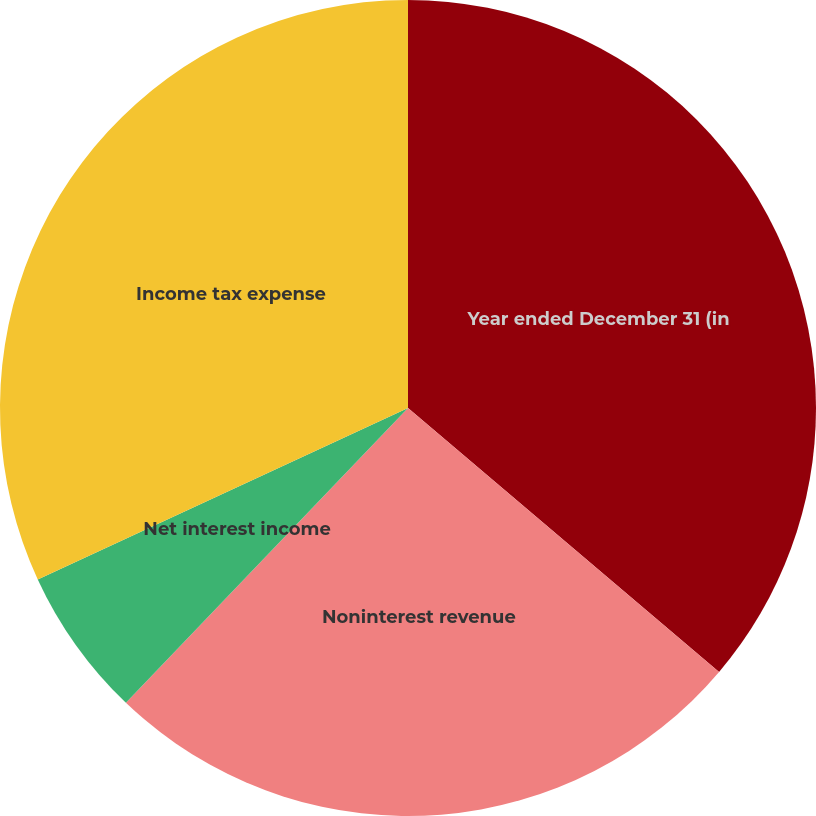<chart> <loc_0><loc_0><loc_500><loc_500><pie_chart><fcel>Year ended December 31 (in<fcel>Noninterest revenue<fcel>Net interest income<fcel>Income tax expense<nl><fcel>36.2%<fcel>25.95%<fcel>5.95%<fcel>31.9%<nl></chart> 